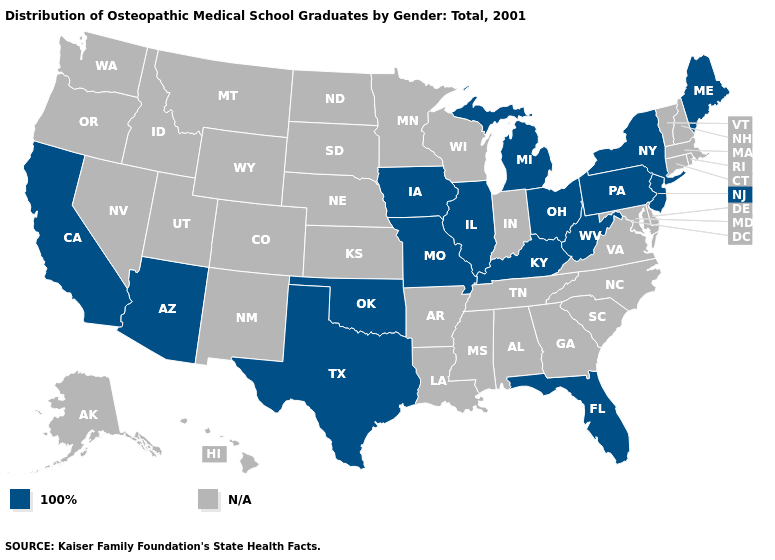What is the value of Connecticut?
Give a very brief answer. N/A. What is the lowest value in states that border Oklahoma?
Concise answer only. 100%. Name the states that have a value in the range N/A?
Write a very short answer. Alabama, Alaska, Arkansas, Colorado, Connecticut, Delaware, Georgia, Hawaii, Idaho, Indiana, Kansas, Louisiana, Maryland, Massachusetts, Minnesota, Mississippi, Montana, Nebraska, Nevada, New Hampshire, New Mexico, North Carolina, North Dakota, Oregon, Rhode Island, South Carolina, South Dakota, Tennessee, Utah, Vermont, Virginia, Washington, Wisconsin, Wyoming. Name the states that have a value in the range N/A?
Answer briefly. Alabama, Alaska, Arkansas, Colorado, Connecticut, Delaware, Georgia, Hawaii, Idaho, Indiana, Kansas, Louisiana, Maryland, Massachusetts, Minnesota, Mississippi, Montana, Nebraska, Nevada, New Hampshire, New Mexico, North Carolina, North Dakota, Oregon, Rhode Island, South Carolina, South Dakota, Tennessee, Utah, Vermont, Virginia, Washington, Wisconsin, Wyoming. What is the value of Rhode Island?
Concise answer only. N/A. Name the states that have a value in the range 100%?
Answer briefly. Arizona, California, Florida, Illinois, Iowa, Kentucky, Maine, Michigan, Missouri, New Jersey, New York, Ohio, Oklahoma, Pennsylvania, Texas, West Virginia. Is the legend a continuous bar?
Keep it brief. No. What is the lowest value in the USA?
Quick response, please. 100%. What is the value of Colorado?
Be succinct. N/A. Name the states that have a value in the range 100%?
Short answer required. Arizona, California, Florida, Illinois, Iowa, Kentucky, Maine, Michigan, Missouri, New Jersey, New York, Ohio, Oklahoma, Pennsylvania, Texas, West Virginia. Which states have the highest value in the USA?
Quick response, please. Arizona, California, Florida, Illinois, Iowa, Kentucky, Maine, Michigan, Missouri, New Jersey, New York, Ohio, Oklahoma, Pennsylvania, Texas, West Virginia. 